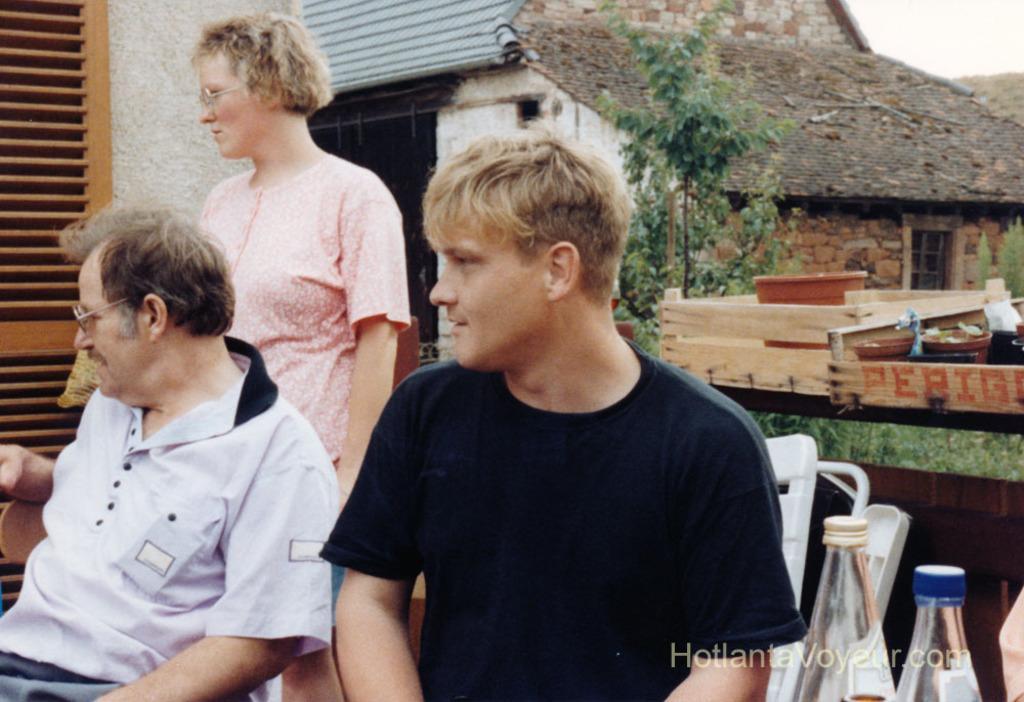Please provide a concise description of this image. Here we can see 3 people, two of them are sitting on chairs and the lady is standing behind them, the bottom right side we can see a couple of Bottles And behind them there is a house and there is a tree in front of the house 